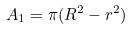Convert formula to latex. <formula><loc_0><loc_0><loc_500><loc_500>A _ { 1 } = \pi ( R ^ { 2 } - r ^ { 2 } )</formula> 